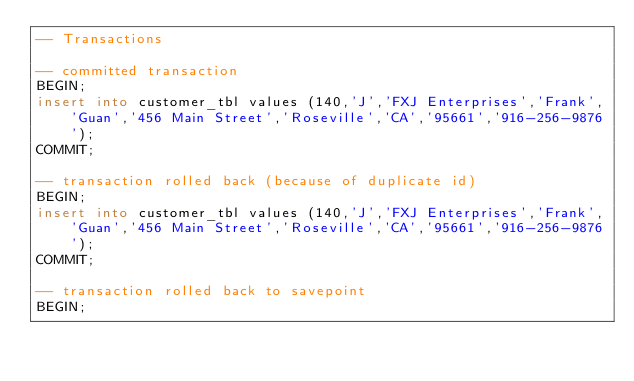Convert code to text. <code><loc_0><loc_0><loc_500><loc_500><_SQL_>-- Transactions

-- committed transaction
BEGIN;
insert into customer_tbl values (140,'J','FXJ Enterprises','Frank','Guan','456 Main Street','Roseville','CA','95661','916-256-9876');
COMMIT;

-- transaction rolled back (because of duplicate id)
BEGIN;
insert into customer_tbl values (140,'J','FXJ Enterprises','Frank','Guan','456 Main Street','Roseville','CA','95661','916-256-9876');
COMMIT;

-- transaction rolled back to savepoint
BEGIN;</code> 